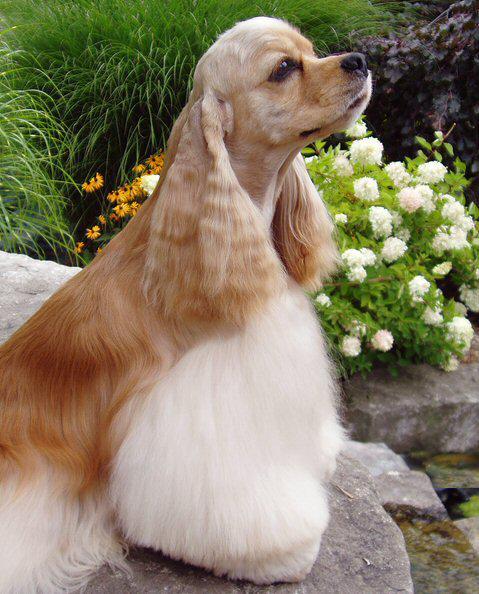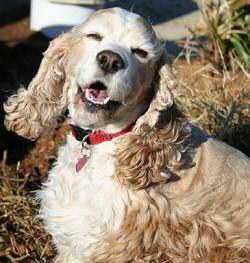The first image is the image on the left, the second image is the image on the right. Given the left and right images, does the statement "A person is tending to the dog in one of the images." hold true? Answer yes or no. No. 